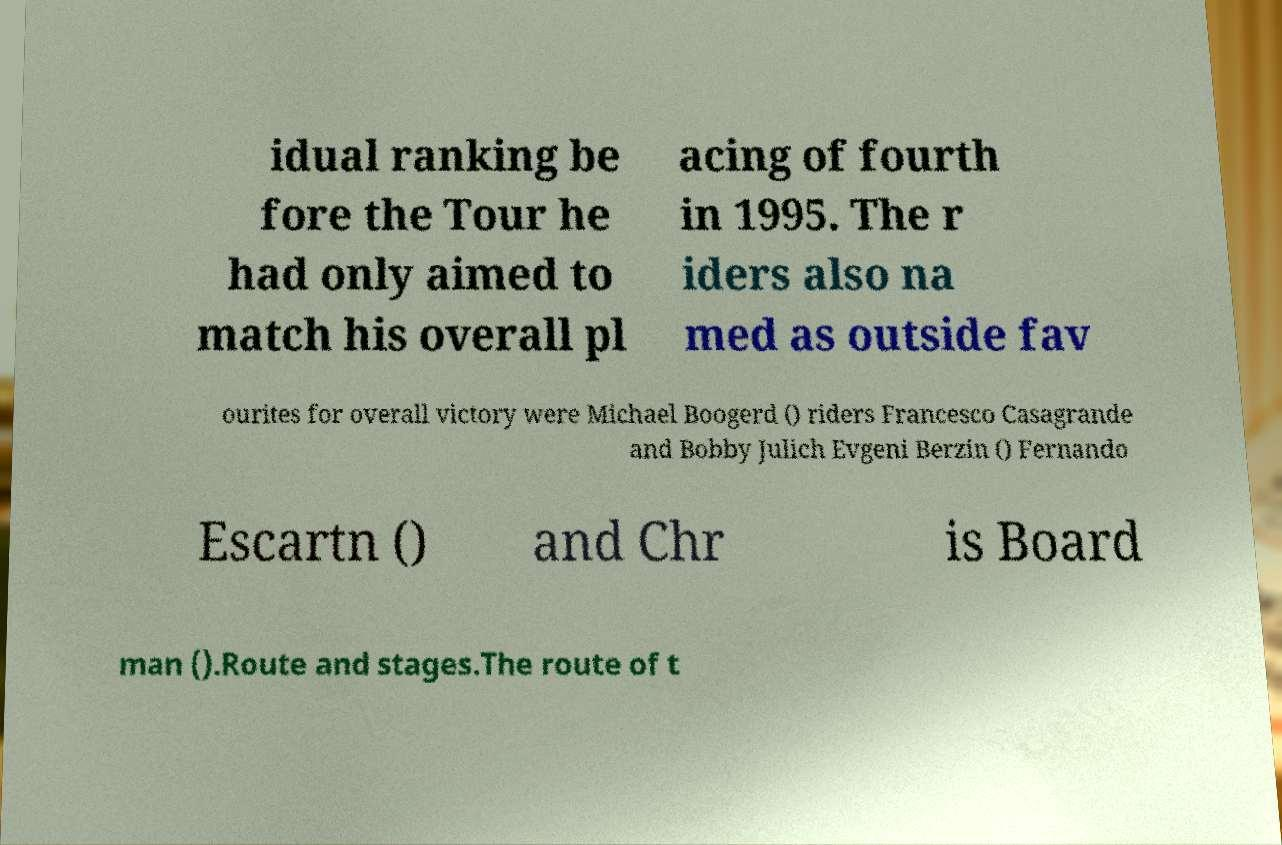Could you extract and type out the text from this image? idual ranking be fore the Tour he had only aimed to match his overall pl acing of fourth in 1995. The r iders also na med as outside fav ourites for overall victory were Michael Boogerd () riders Francesco Casagrande and Bobby Julich Evgeni Berzin () Fernando Escartn () and Chr is Board man ().Route and stages.The route of t 